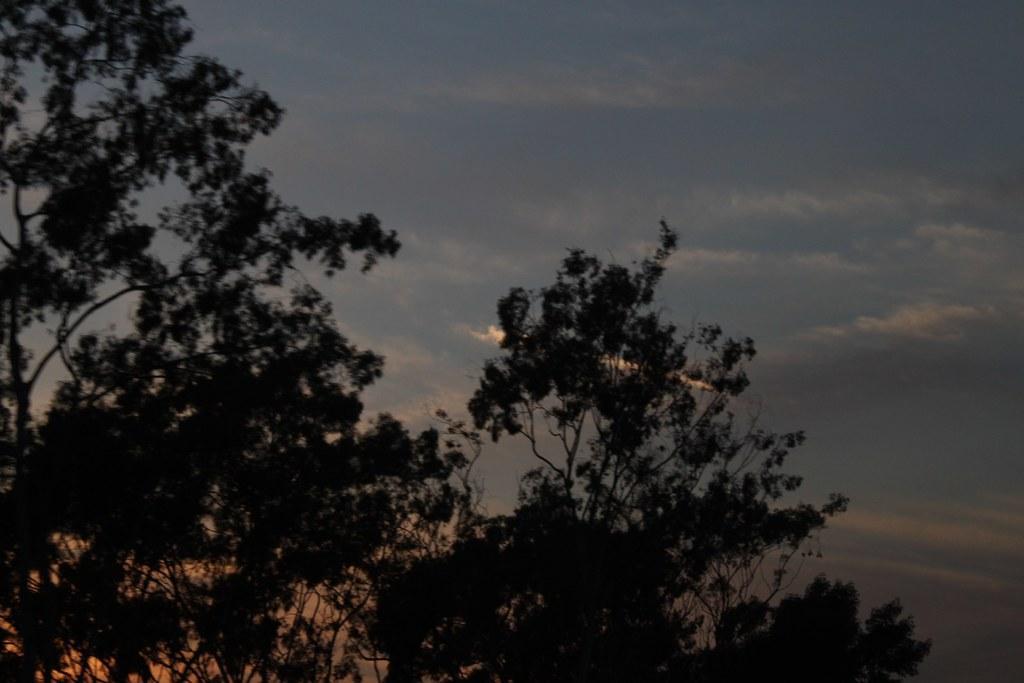Please provide a concise description of this image. This is an outside view. In this image I can see many trees. At the top of the image I can see the sky and clouds. 